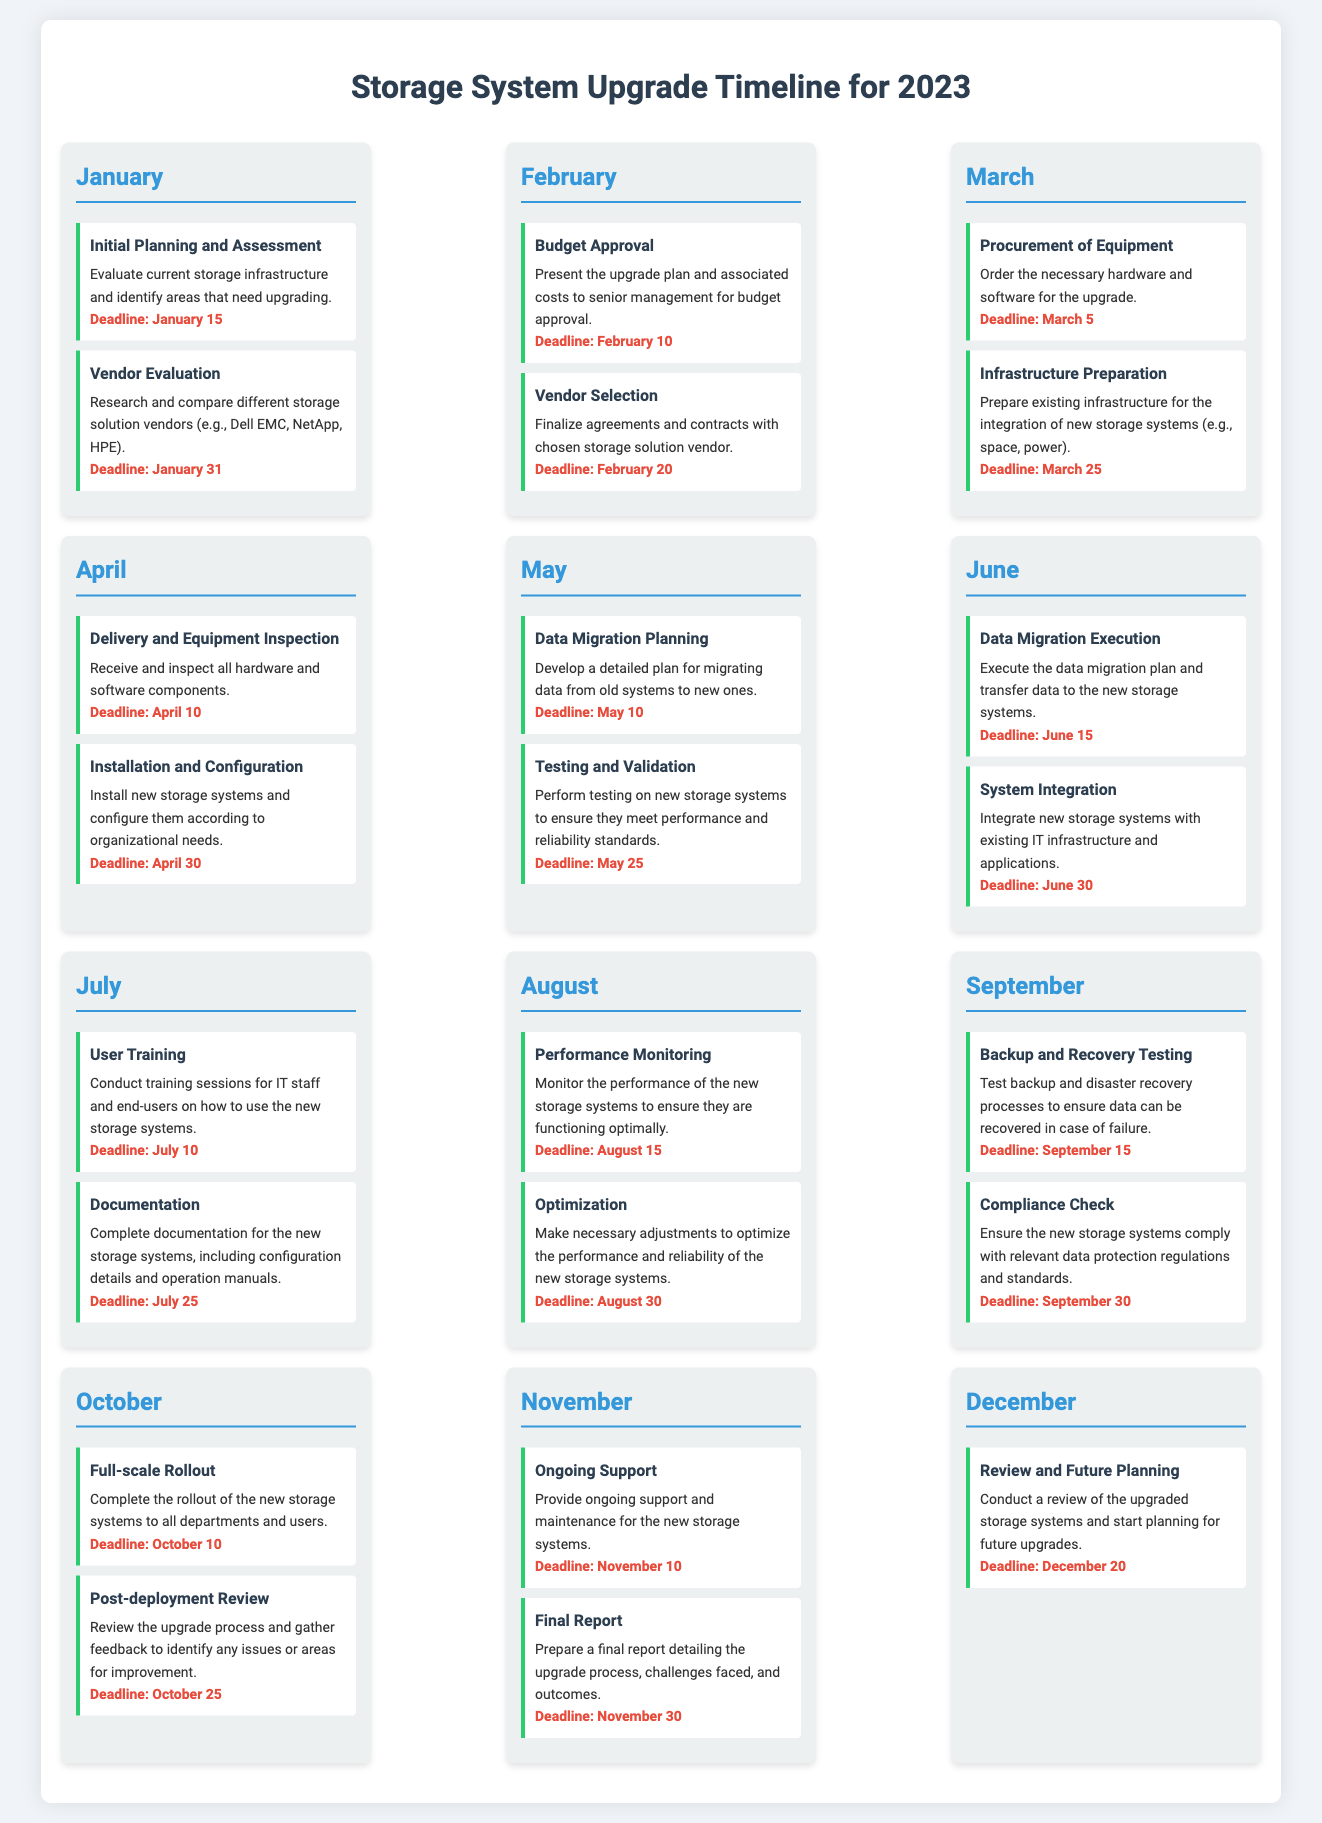what is the deadline for Initial Planning and Assessment? The deadline for Initial Planning and Assessment is mentioned in January’s tasks, which states January 15.
Answer: January 15 what task is scheduled for March 25? The task scheduled for March 25 is Infrastructure Preparation.
Answer: Infrastructure Preparation how many tasks are there in July? There are two tasks listed for July, which are User Training and Documentation.
Answer: Two what is the deadline for Data Migration Execution? The deadline for Data Migration Execution is specified in June’s tasks, which is June 15.
Answer: June 15 which month includes Budget Approval? The month that includes Budget Approval is February, as detailed in the task list.
Answer: February what are the final tasks listed for the year? The final tasks listed for the year are Review and Future Planning in December.
Answer: Review and Future Planning how many months have tasks listed for Performance Monitoring? The document specifically includes only one task for Performance Monitoring, which is listed in August.
Answer: One when is the Post-deployment Review scheduled? The Post-deployment Review is scheduled for October 25, as indicated in the timeline.
Answer: October 25 which month has the task for Compliance Check? The month that has the task for Compliance Check is September.
Answer: September what is the last task of the storage system upgrade timeline? The last task of the storage system upgrade timeline is Review and Future Planning.
Answer: Review and Future Planning 